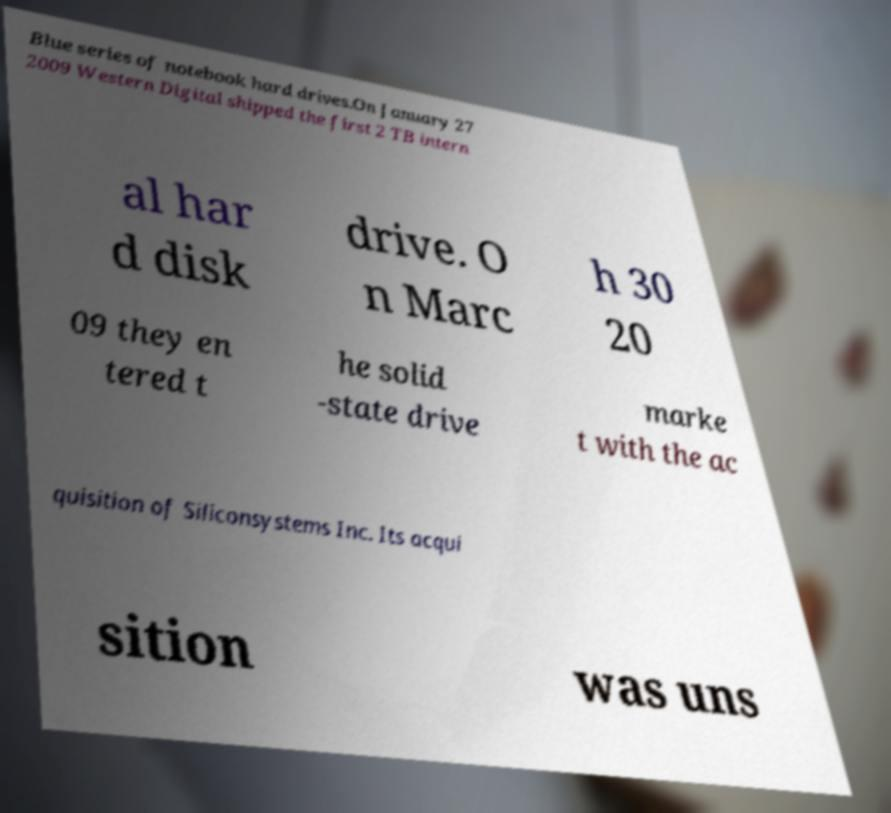Could you assist in decoding the text presented in this image and type it out clearly? Blue series of notebook hard drives.On January 27 2009 Western Digital shipped the first 2 TB intern al har d disk drive. O n Marc h 30 20 09 they en tered t he solid -state drive marke t with the ac quisition of Siliconsystems Inc. Its acqui sition was uns 